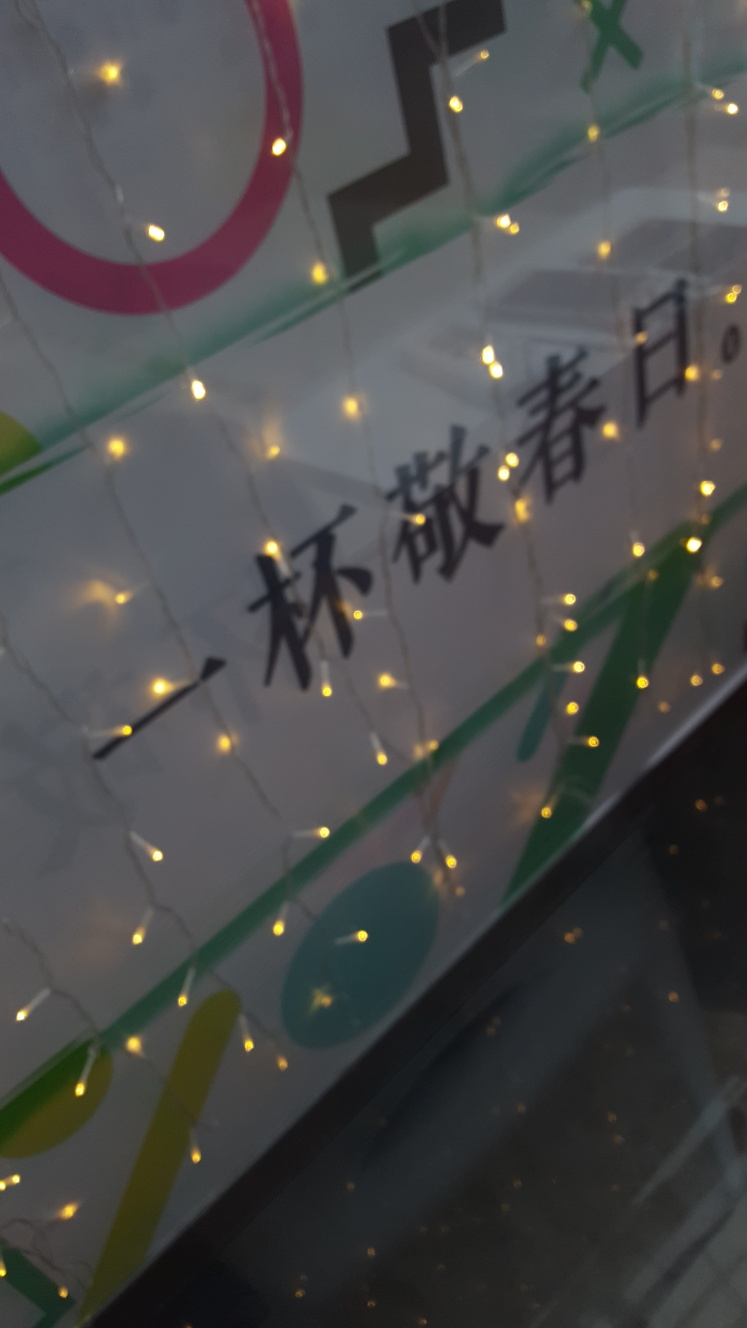What is the mood or atmosphere that the light arrangement in this picture conveys? The warm glow of the lights against the semi-translucent backdrop creates a welcoming and cozy atmosphere. This type of lighting arrangement often suggests a festive or celebratory mood, reminiscent of holiday decorations or intimate gatherings. 